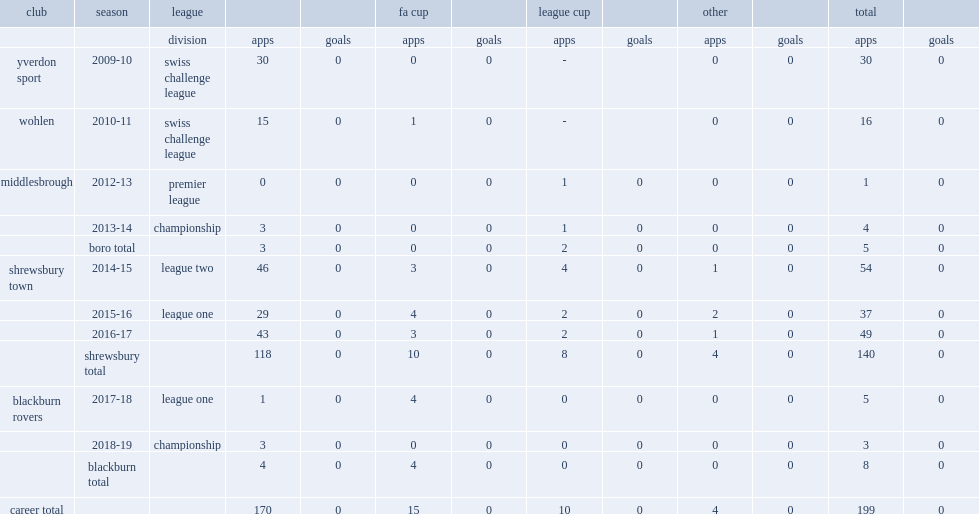How many fa cup games did jayson leutwiler appear in 2016-17? 3.0. How many league cup did jayson leutwiler appear in 2016-17? 2.0. 